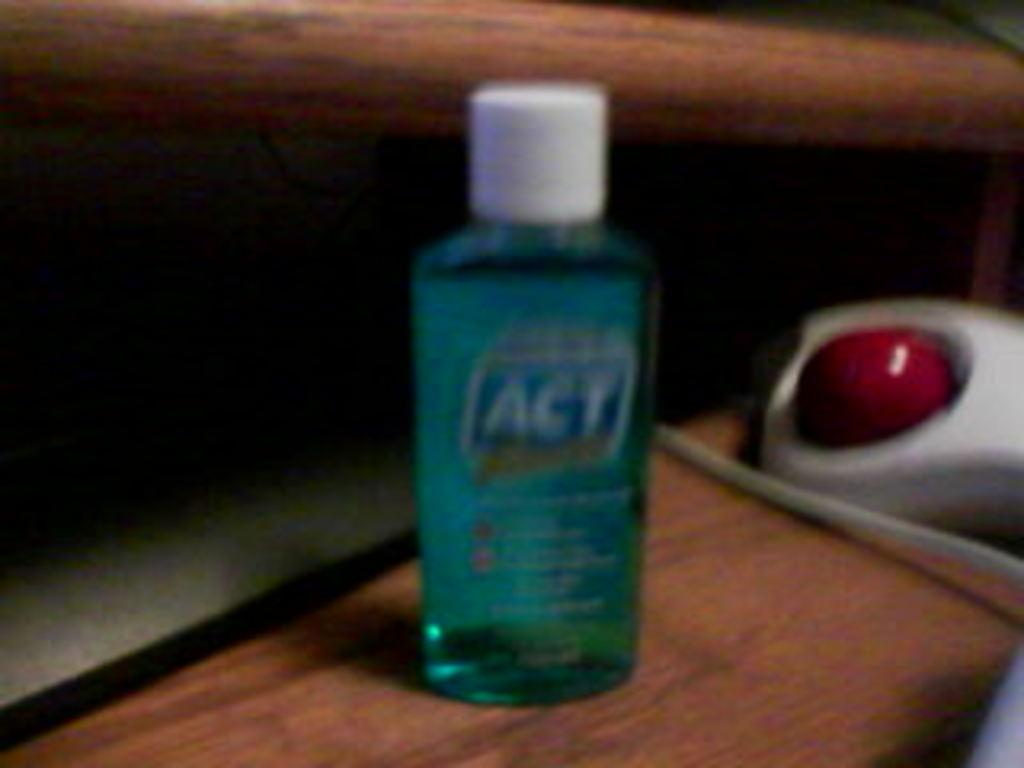<image>
Relay a brief, clear account of the picture shown. a blurry shot of ACT blue liquid on a wooden surface 